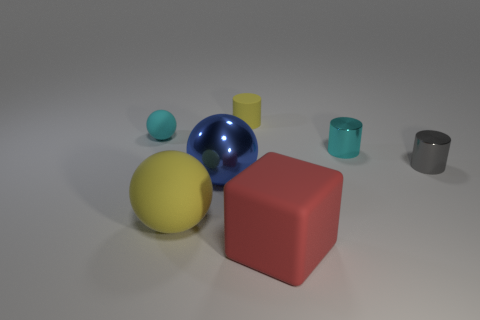There is a yellow matte thing that is in front of the metallic cylinder that is in front of the cyan shiny cylinder; is there a tiny gray cylinder left of it?
Ensure brevity in your answer.  No. What number of large blue shiny things are on the right side of the tiny cyan metal thing?
Your response must be concise. 0. What number of other rubber balls have the same color as the big rubber sphere?
Provide a short and direct response. 0. How many objects are either tiny things in front of the tiny yellow thing or objects left of the rubber block?
Make the answer very short. 6. Are there more small yellow objects than large green balls?
Your answer should be very brief. Yes. What is the color of the big ball right of the large matte ball?
Give a very brief answer. Blue. Is the shape of the gray metal thing the same as the blue object?
Make the answer very short. No. The matte object that is in front of the cyan cylinder and on the left side of the yellow cylinder is what color?
Make the answer very short. Yellow. There is a yellow thing behind the gray cylinder; is it the same size as the matte sphere behind the large blue shiny object?
Give a very brief answer. Yes. What number of objects are matte spheres that are right of the small cyan rubber sphere or large blue blocks?
Offer a terse response. 1. 